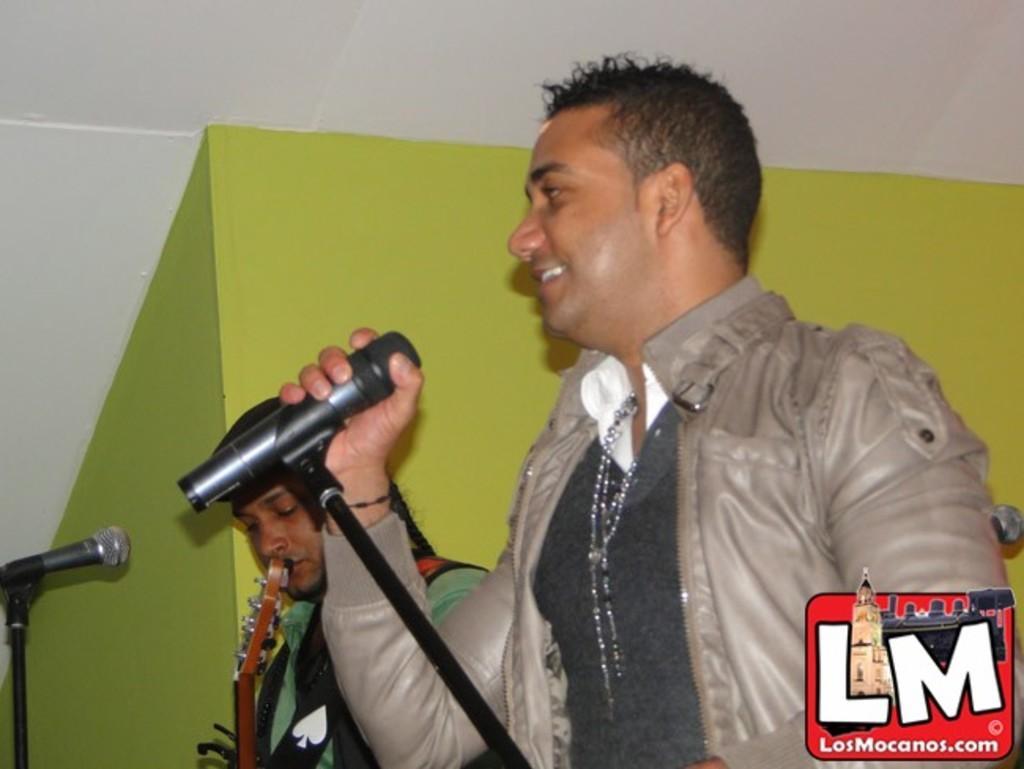Can you describe this image briefly? In this image I can see two persons. One of the person is holding a mike , which is with mike stand. Also there is another mike with stand and there is a musical instrument. There are walls and in the bottom right corner there is a water mark. 